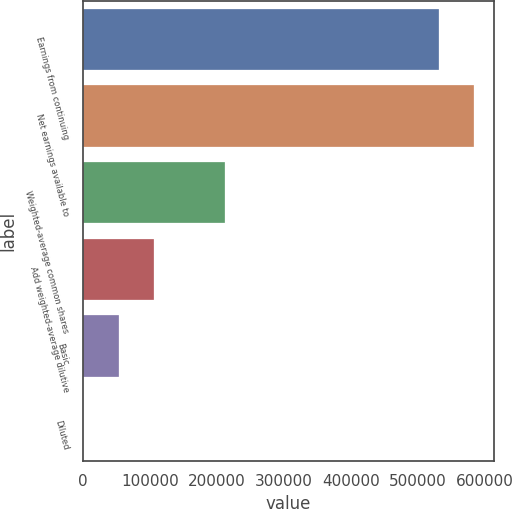<chart> <loc_0><loc_0><loc_500><loc_500><bar_chart><fcel>Earnings from continuing<fcel>Net earnings available to<fcel>Weighted-average common shares<fcel>Add weighted-average dilutive<fcel>Basic<fcel>Diluted<nl><fcel>531965<fcel>585161<fcel>212790<fcel>106399<fcel>53203<fcel>7.25<nl></chart> 